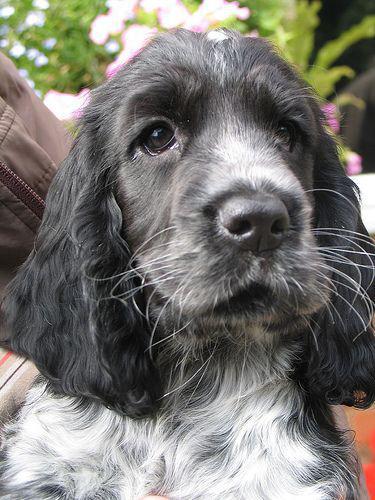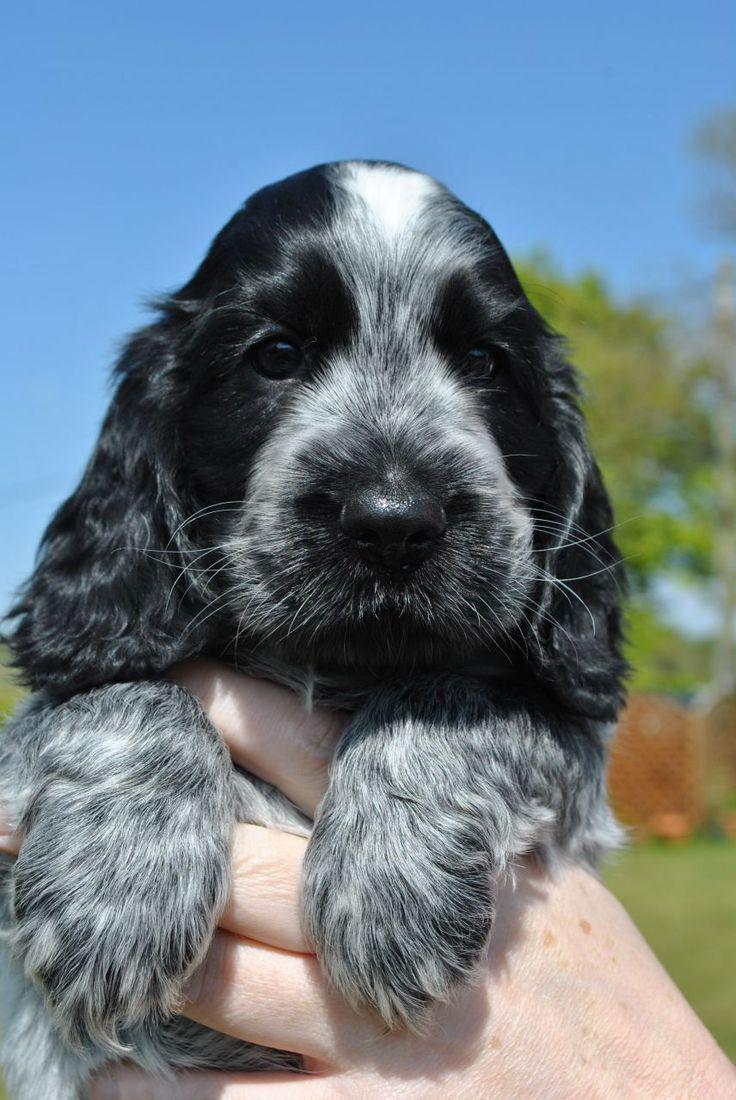The first image is the image on the left, the second image is the image on the right. For the images displayed, is the sentence "In one image, a small black and gray dog is being held outdoors with its front paws draped over a hand, while a similar dog in a second image is sitting outdoors." factually correct? Answer yes or no. Yes. The first image is the image on the left, the second image is the image on the right. Examine the images to the left and right. Is the description "A floppy eared dog is in contact with a stick-like object in one image." accurate? Answer yes or no. No. 